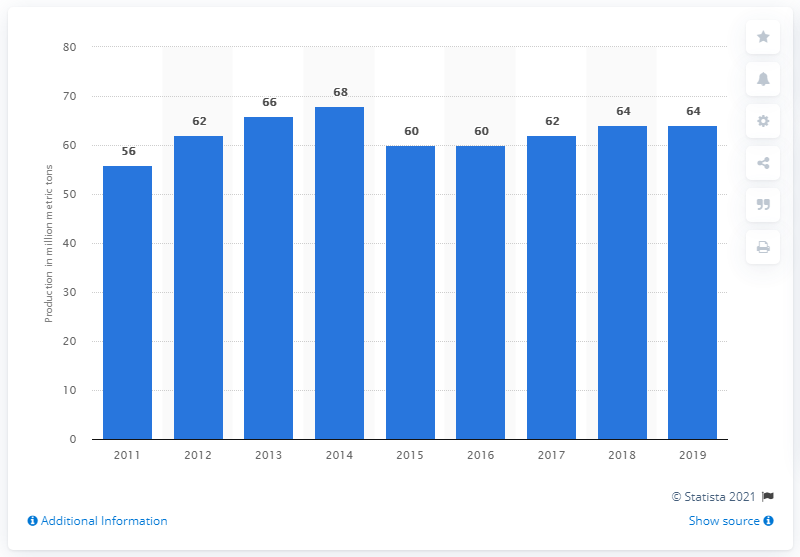List a handful of essential elements in this visual. According to estimates, Russia is projected to produce approximately 62 million metric tons of cement in 2017. 